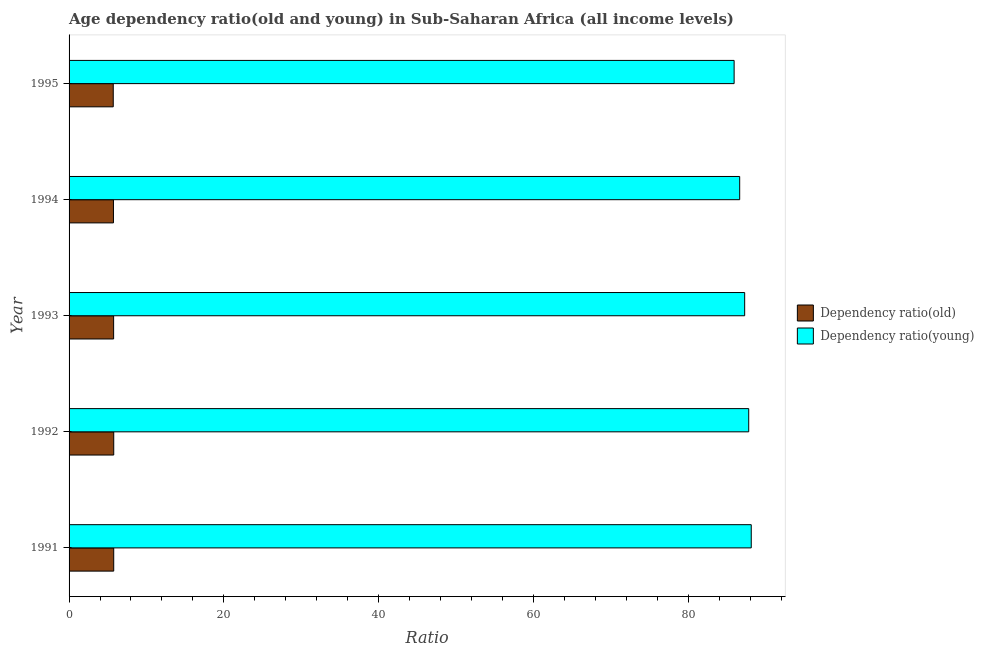Are the number of bars per tick equal to the number of legend labels?
Provide a short and direct response. Yes. Are the number of bars on each tick of the Y-axis equal?
Offer a very short reply. Yes. How many bars are there on the 2nd tick from the top?
Give a very brief answer. 2. What is the label of the 3rd group of bars from the top?
Your answer should be very brief. 1993. In how many cases, is the number of bars for a given year not equal to the number of legend labels?
Provide a succinct answer. 0. What is the age dependency ratio(old) in 1994?
Your answer should be very brief. 5.74. Across all years, what is the maximum age dependency ratio(young)?
Provide a succinct answer. 88.15. Across all years, what is the minimum age dependency ratio(young)?
Offer a terse response. 85.93. In which year was the age dependency ratio(young) maximum?
Offer a terse response. 1991. In which year was the age dependency ratio(young) minimum?
Provide a succinct answer. 1995. What is the total age dependency ratio(young) in the graph?
Your answer should be very brief. 435.85. What is the difference between the age dependency ratio(old) in 1993 and that in 1994?
Offer a very short reply. 0.02. What is the difference between the age dependency ratio(old) in 1992 and the age dependency ratio(young) in 1991?
Your response must be concise. -82.38. What is the average age dependency ratio(old) per year?
Ensure brevity in your answer.  5.75. In the year 1993, what is the difference between the age dependency ratio(old) and age dependency ratio(young)?
Offer a very short reply. -81.54. What is the ratio of the age dependency ratio(young) in 1991 to that in 1995?
Keep it short and to the point. 1.03. What is the difference between the highest and the lowest age dependency ratio(old)?
Keep it short and to the point. 0.06. In how many years, is the age dependency ratio(young) greater than the average age dependency ratio(young) taken over all years?
Offer a very short reply. 3. Is the sum of the age dependency ratio(old) in 1992 and 1993 greater than the maximum age dependency ratio(young) across all years?
Give a very brief answer. No. What does the 2nd bar from the top in 1991 represents?
Provide a short and direct response. Dependency ratio(old). What does the 1st bar from the bottom in 1992 represents?
Ensure brevity in your answer.  Dependency ratio(old). Are all the bars in the graph horizontal?
Your response must be concise. Yes. How many years are there in the graph?
Ensure brevity in your answer.  5. What is the difference between two consecutive major ticks on the X-axis?
Provide a succinct answer. 20. Does the graph contain any zero values?
Give a very brief answer. No. How are the legend labels stacked?
Your answer should be compact. Vertical. What is the title of the graph?
Keep it short and to the point. Age dependency ratio(old and young) in Sub-Saharan Africa (all income levels). Does "constant 2005 US$" appear as one of the legend labels in the graph?
Your answer should be compact. No. What is the label or title of the X-axis?
Provide a short and direct response. Ratio. What is the label or title of the Y-axis?
Ensure brevity in your answer.  Year. What is the Ratio of Dependency ratio(old) in 1991?
Your response must be concise. 5.77. What is the Ratio of Dependency ratio(young) in 1991?
Provide a succinct answer. 88.15. What is the Ratio of Dependency ratio(old) in 1992?
Give a very brief answer. 5.77. What is the Ratio of Dependency ratio(young) in 1992?
Ensure brevity in your answer.  87.82. What is the Ratio of Dependency ratio(old) in 1993?
Your answer should be compact. 5.76. What is the Ratio of Dependency ratio(young) in 1993?
Make the answer very short. 87.3. What is the Ratio of Dependency ratio(old) in 1994?
Keep it short and to the point. 5.74. What is the Ratio in Dependency ratio(young) in 1994?
Make the answer very short. 86.65. What is the Ratio in Dependency ratio(old) in 1995?
Give a very brief answer. 5.71. What is the Ratio of Dependency ratio(young) in 1995?
Your answer should be compact. 85.93. Across all years, what is the maximum Ratio of Dependency ratio(old)?
Provide a succinct answer. 5.77. Across all years, what is the maximum Ratio of Dependency ratio(young)?
Make the answer very short. 88.15. Across all years, what is the minimum Ratio of Dependency ratio(old)?
Your response must be concise. 5.71. Across all years, what is the minimum Ratio of Dependency ratio(young)?
Your answer should be very brief. 85.93. What is the total Ratio in Dependency ratio(old) in the graph?
Provide a succinct answer. 28.74. What is the total Ratio of Dependency ratio(young) in the graph?
Your response must be concise. 435.85. What is the difference between the Ratio in Dependency ratio(old) in 1991 and that in 1992?
Provide a short and direct response. -0. What is the difference between the Ratio in Dependency ratio(young) in 1991 and that in 1992?
Your answer should be very brief. 0.33. What is the difference between the Ratio in Dependency ratio(old) in 1991 and that in 1993?
Make the answer very short. 0.01. What is the difference between the Ratio in Dependency ratio(young) in 1991 and that in 1993?
Keep it short and to the point. 0.85. What is the difference between the Ratio in Dependency ratio(old) in 1991 and that in 1994?
Ensure brevity in your answer.  0.03. What is the difference between the Ratio of Dependency ratio(young) in 1991 and that in 1994?
Your answer should be compact. 1.49. What is the difference between the Ratio in Dependency ratio(old) in 1991 and that in 1995?
Your answer should be compact. 0.06. What is the difference between the Ratio of Dependency ratio(young) in 1991 and that in 1995?
Make the answer very short. 2.21. What is the difference between the Ratio of Dependency ratio(old) in 1992 and that in 1993?
Offer a terse response. 0.01. What is the difference between the Ratio of Dependency ratio(young) in 1992 and that in 1993?
Keep it short and to the point. 0.52. What is the difference between the Ratio of Dependency ratio(old) in 1992 and that in 1994?
Ensure brevity in your answer.  0.03. What is the difference between the Ratio of Dependency ratio(young) in 1992 and that in 1994?
Make the answer very short. 1.17. What is the difference between the Ratio of Dependency ratio(old) in 1992 and that in 1995?
Offer a terse response. 0.06. What is the difference between the Ratio of Dependency ratio(young) in 1992 and that in 1995?
Give a very brief answer. 1.89. What is the difference between the Ratio in Dependency ratio(old) in 1993 and that in 1994?
Keep it short and to the point. 0.02. What is the difference between the Ratio of Dependency ratio(young) in 1993 and that in 1994?
Your answer should be very brief. 0.64. What is the difference between the Ratio in Dependency ratio(old) in 1993 and that in 1995?
Offer a very short reply. 0.05. What is the difference between the Ratio in Dependency ratio(young) in 1993 and that in 1995?
Give a very brief answer. 1.36. What is the difference between the Ratio in Dependency ratio(old) in 1994 and that in 1995?
Keep it short and to the point. 0.03. What is the difference between the Ratio of Dependency ratio(young) in 1994 and that in 1995?
Offer a very short reply. 0.72. What is the difference between the Ratio of Dependency ratio(old) in 1991 and the Ratio of Dependency ratio(young) in 1992?
Provide a short and direct response. -82.05. What is the difference between the Ratio in Dependency ratio(old) in 1991 and the Ratio in Dependency ratio(young) in 1993?
Your answer should be very brief. -81.53. What is the difference between the Ratio of Dependency ratio(old) in 1991 and the Ratio of Dependency ratio(young) in 1994?
Provide a succinct answer. -80.88. What is the difference between the Ratio in Dependency ratio(old) in 1991 and the Ratio in Dependency ratio(young) in 1995?
Ensure brevity in your answer.  -80.17. What is the difference between the Ratio in Dependency ratio(old) in 1992 and the Ratio in Dependency ratio(young) in 1993?
Your answer should be compact. -81.53. What is the difference between the Ratio of Dependency ratio(old) in 1992 and the Ratio of Dependency ratio(young) in 1994?
Provide a short and direct response. -80.88. What is the difference between the Ratio of Dependency ratio(old) in 1992 and the Ratio of Dependency ratio(young) in 1995?
Your answer should be very brief. -80.16. What is the difference between the Ratio in Dependency ratio(old) in 1993 and the Ratio in Dependency ratio(young) in 1994?
Offer a very short reply. -80.9. What is the difference between the Ratio of Dependency ratio(old) in 1993 and the Ratio of Dependency ratio(young) in 1995?
Provide a succinct answer. -80.18. What is the difference between the Ratio of Dependency ratio(old) in 1994 and the Ratio of Dependency ratio(young) in 1995?
Offer a terse response. -80.2. What is the average Ratio in Dependency ratio(old) per year?
Your response must be concise. 5.75. What is the average Ratio in Dependency ratio(young) per year?
Your answer should be compact. 87.17. In the year 1991, what is the difference between the Ratio in Dependency ratio(old) and Ratio in Dependency ratio(young)?
Offer a very short reply. -82.38. In the year 1992, what is the difference between the Ratio in Dependency ratio(old) and Ratio in Dependency ratio(young)?
Keep it short and to the point. -82.05. In the year 1993, what is the difference between the Ratio in Dependency ratio(old) and Ratio in Dependency ratio(young)?
Ensure brevity in your answer.  -81.54. In the year 1994, what is the difference between the Ratio in Dependency ratio(old) and Ratio in Dependency ratio(young)?
Your answer should be very brief. -80.92. In the year 1995, what is the difference between the Ratio of Dependency ratio(old) and Ratio of Dependency ratio(young)?
Make the answer very short. -80.23. What is the ratio of the Ratio in Dependency ratio(young) in 1991 to that in 1992?
Your answer should be compact. 1. What is the ratio of the Ratio in Dependency ratio(young) in 1991 to that in 1993?
Give a very brief answer. 1.01. What is the ratio of the Ratio of Dependency ratio(young) in 1991 to that in 1994?
Your answer should be compact. 1.02. What is the ratio of the Ratio of Dependency ratio(old) in 1991 to that in 1995?
Your answer should be very brief. 1.01. What is the ratio of the Ratio of Dependency ratio(young) in 1991 to that in 1995?
Provide a succinct answer. 1.03. What is the ratio of the Ratio in Dependency ratio(young) in 1992 to that in 1993?
Offer a terse response. 1.01. What is the ratio of the Ratio in Dependency ratio(young) in 1992 to that in 1994?
Provide a succinct answer. 1.01. What is the ratio of the Ratio of Dependency ratio(old) in 1992 to that in 1995?
Offer a very short reply. 1.01. What is the ratio of the Ratio in Dependency ratio(young) in 1992 to that in 1995?
Your response must be concise. 1.02. What is the ratio of the Ratio in Dependency ratio(young) in 1993 to that in 1994?
Your answer should be compact. 1.01. What is the ratio of the Ratio in Dependency ratio(old) in 1993 to that in 1995?
Your answer should be compact. 1.01. What is the ratio of the Ratio in Dependency ratio(young) in 1993 to that in 1995?
Provide a succinct answer. 1.02. What is the ratio of the Ratio of Dependency ratio(old) in 1994 to that in 1995?
Your answer should be very brief. 1. What is the ratio of the Ratio of Dependency ratio(young) in 1994 to that in 1995?
Offer a very short reply. 1.01. What is the difference between the highest and the second highest Ratio in Dependency ratio(old)?
Your answer should be compact. 0. What is the difference between the highest and the second highest Ratio of Dependency ratio(young)?
Provide a succinct answer. 0.33. What is the difference between the highest and the lowest Ratio in Dependency ratio(old)?
Provide a succinct answer. 0.06. What is the difference between the highest and the lowest Ratio of Dependency ratio(young)?
Provide a short and direct response. 2.21. 